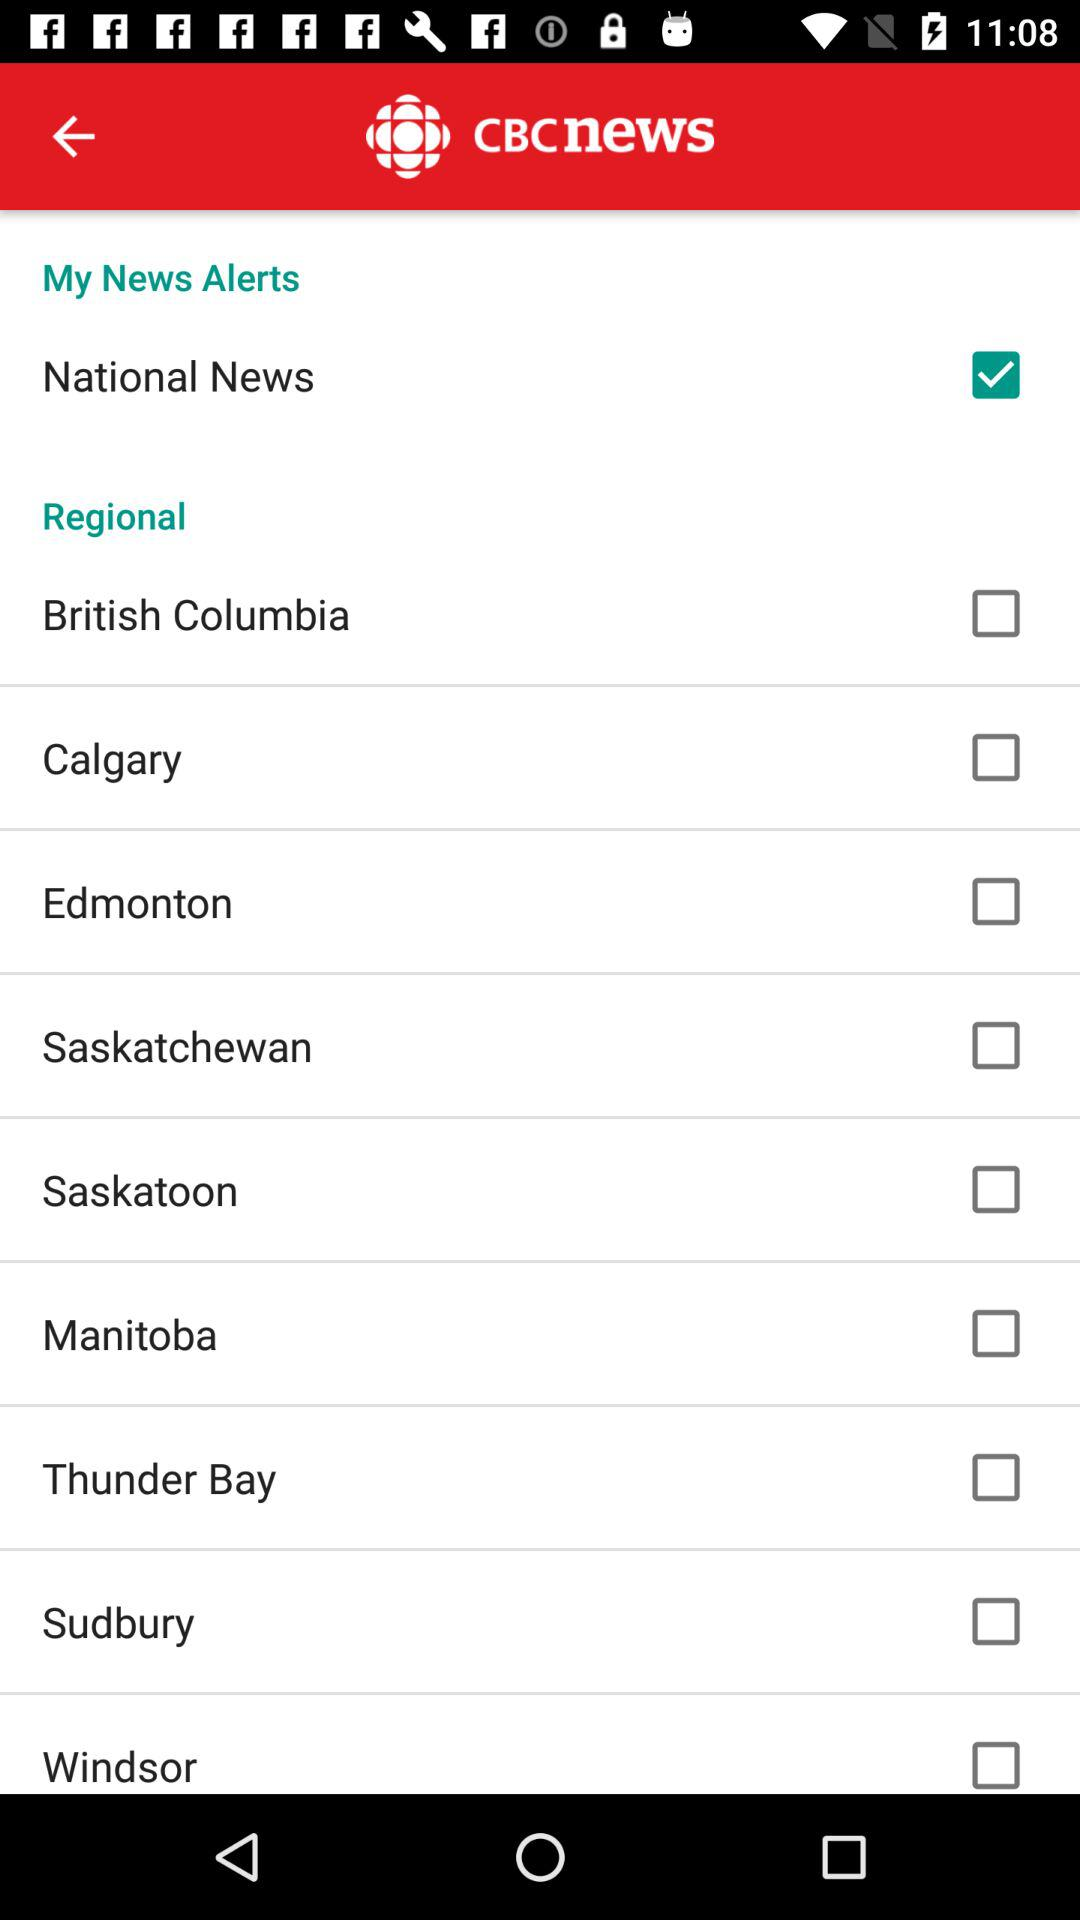What is the application name? The application name is "CBC NEWS". 